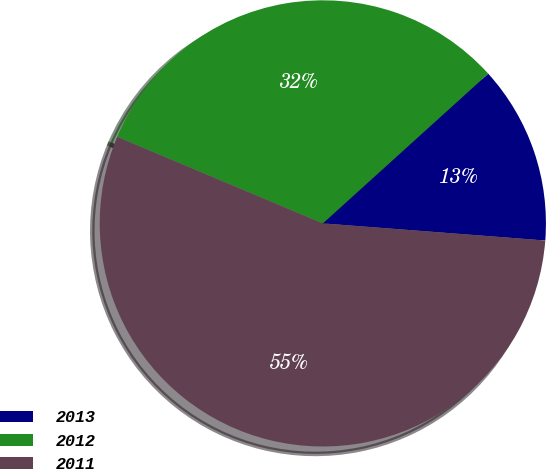Convert chart to OTSL. <chart><loc_0><loc_0><loc_500><loc_500><pie_chart><fcel>2013<fcel>2012<fcel>2011<nl><fcel>12.93%<fcel>31.95%<fcel>55.12%<nl></chart> 